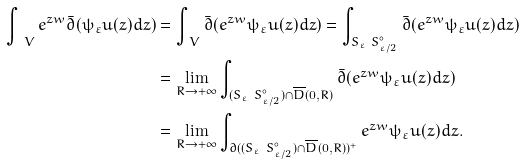<formula> <loc_0><loc_0><loc_500><loc_500>\int _ { \ V } e ^ { z w } \bar { \partial } ( \psi _ { \varepsilon } u ( z ) d z ) & = \int _ { \ V } \bar { \partial } ( e ^ { z w } \psi _ { \varepsilon } u ( z ) d z ) = \int _ { S _ { \varepsilon } \ S ^ { \circ } _ { \varepsilon / 2 } } \bar { \partial } ( e ^ { z w } \psi _ { \varepsilon } u ( z ) d z ) \\ & = \lim _ { R \to + \infty } \int _ { ( S _ { \varepsilon } \ S ^ { \circ } _ { \varepsilon / 2 } ) \cap \overline { D } ( 0 , R ) } \bar { \partial } ( e ^ { z w } \psi _ { \varepsilon } u ( z ) d z ) \\ & = \lim _ { R \to + \infty } \int _ { \partial ( ( S _ { \varepsilon } \ S ^ { \circ } _ { \varepsilon / 2 } ) \cap \overline { D } ( 0 , R ) ) ^ { + } } e ^ { z w } \psi _ { \varepsilon } u ( z ) d z .</formula> 